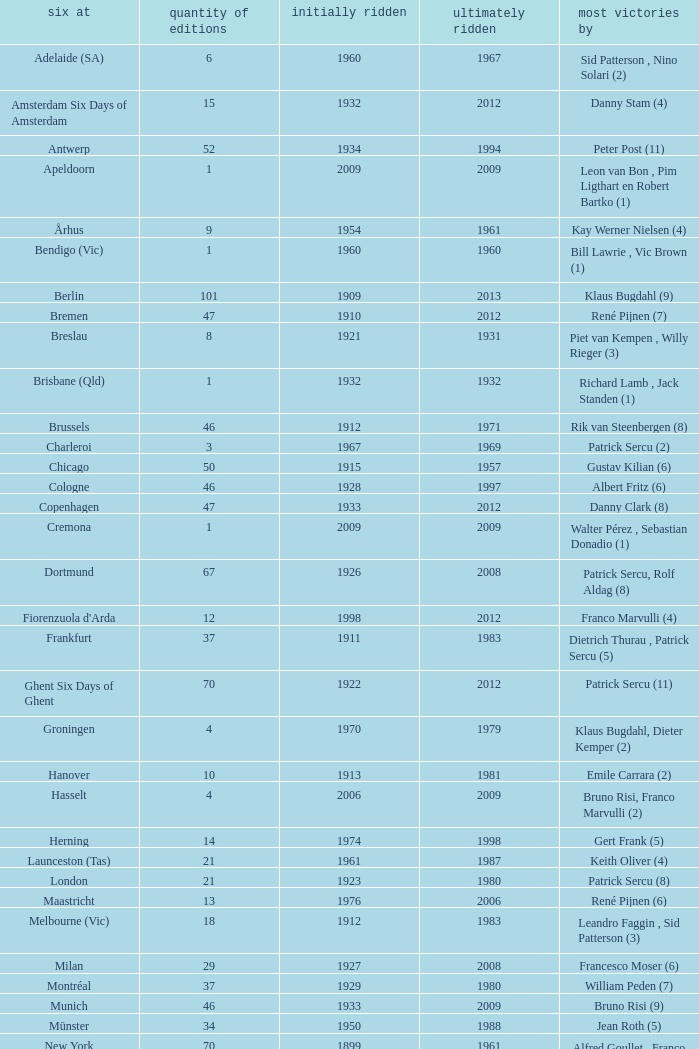How many editions have a most wins value of Franco Marvulli (4)? 1.0. 